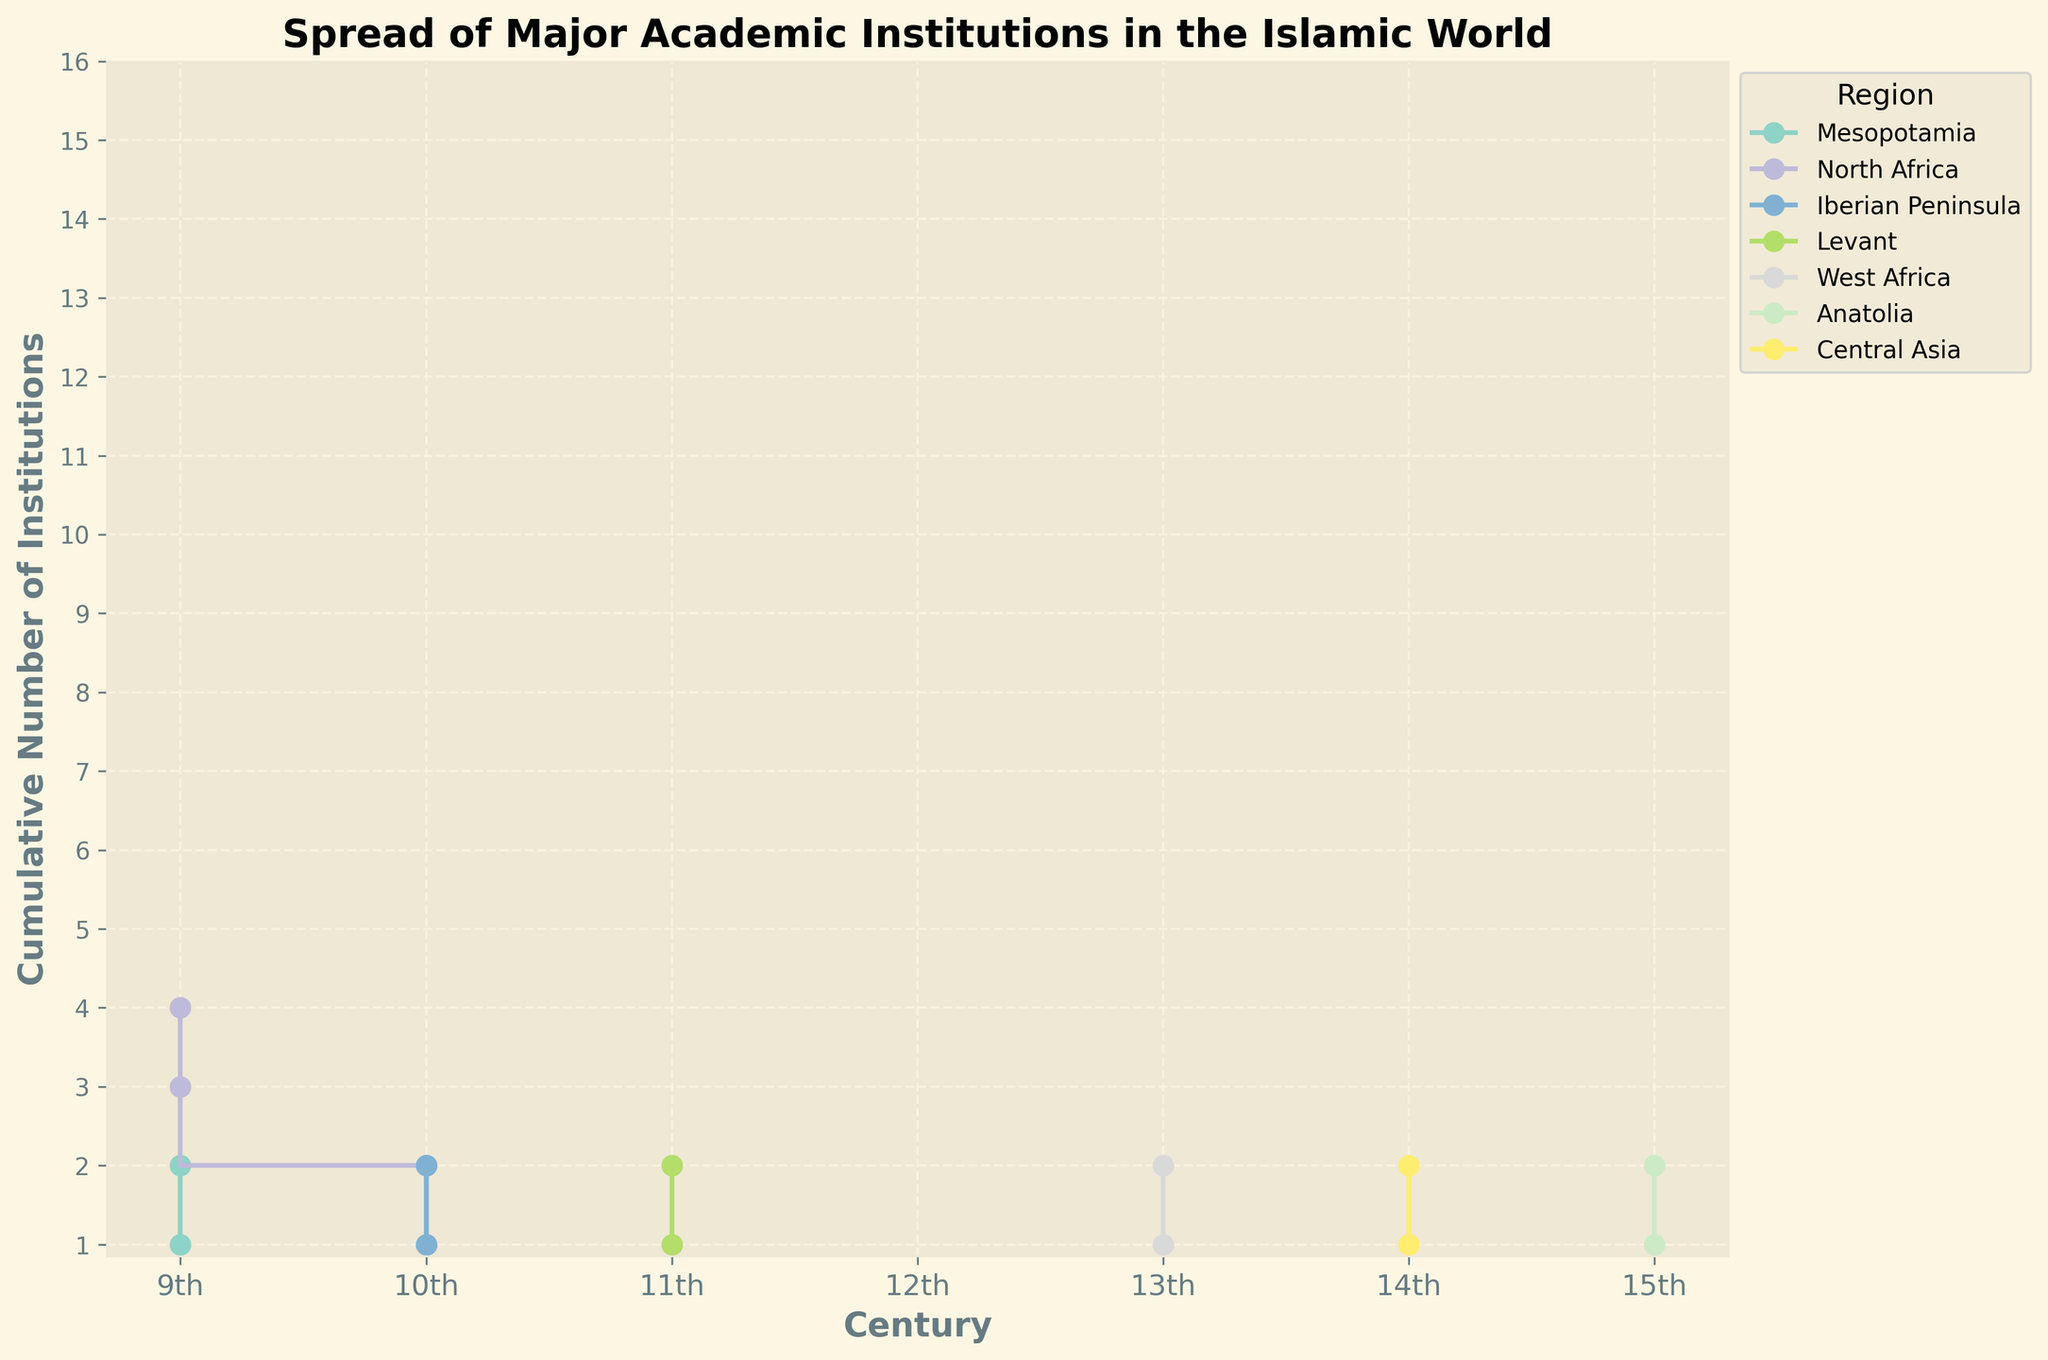What's the title of the plot? The title is typically located at the top of the figure. It is written in a larger and bolded font to make it easily identifiable. In this plot, the title is "Spread of Major Academic Institutions in the Islamic World."
Answer: Spread of Major Academic Institutions in the Islamic World Which region has the earliest data point listed in the plot? To find the earliest data point, look for the first entity on the x-axis (Century) and check the corresponding regions in the legend. The earliest century in the plot is the 9th century. From the legend and the colors associated, it is indicated that Mesopotamia (Baghdad) has the earliest institution.
Answer: Mesopotamia How many regions have their first data points in the 10th century? To find this, look for the starting points after the 9th century on the x-axis. You'll see steps starting in the 10th century, and by matching the colors to the legend, you can count these regions. The regions are North Africa (Cairo), and the Iberian Peninsula (Cordoba).
Answer: 2 Which region shows the highest cumulative number of institutions by the 15th century? Analyze the steps for each region up to the 15th century. The region with the highest final step is the one with the most institutions by that time. The plot shows that North Africa has reached the highest cumulative point by the 15th century.
Answer: North Africa Which century saw the establishment of institutions in Central Asia? Find the step corresponding to Central Asia (matched by color in the legend) and locate the first x-axis value it corresponds to. For Central Asia (Samarkand), it starts in the 14th century.
Answer: 14th century What is the combined number of institutions established in Timbuktu and Istanbul by the 15th century? Locate the steps associated with Timbuktu (West Africa) and Istanbul (Anatolia). Add up the final step values seen next to the 15th century mark. Timbuktu (13th century) has steps reaching 2, and Istanbul (15th century) has steps reaching 2. The combined number is 2 + 2.
Answer: 4 Which region experienced the first major increase in the number of institutions between the 9th and 10th centuries? Identify regions with steps occurring between the 9th and 10th centuries. The region that shows a steeper and earlier increase compared to others is North Africa (Cairo and Fez).
Answer: North Africa Is there any century where no new academic institutions were added in any region? Scan through the x-axis (centuries) and observe the steps. If there is a century without any new steps, that would indicate no additions. However, there are no such gaps in the plot. Every century from the 9th to the 15th shows at least one step.
Answer: No Which two regions have data points in both the 9th and 14th centuries? Identify the regions with steps in both the 9th and the 14th centuries. By observing the steps, Mesopotamia (9th century) and Central Asia (14th century) have steps that match these criteria, but are from different regions. No single region has data points in both centuries.
Answer: None 